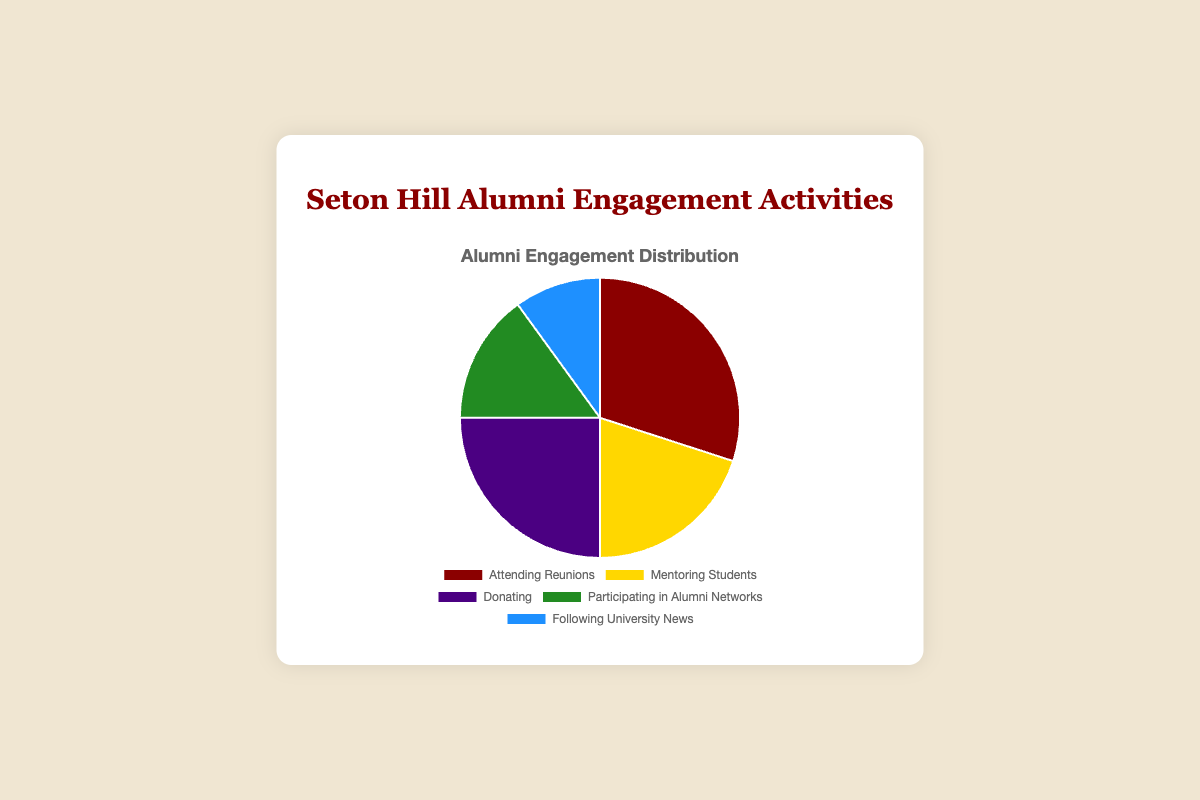Which activity has the highest percentage of alumni engagement? To determine this, look at the percentages for each activity and find the highest one. "Attending Reunions" has the highest percentage at 30%.
Answer: Attending Reunions What is the total percentage of alumni participating in "Mentoring Students" and "Donating"? Add the percentages for "Mentoring Students" (20%) and "Donating" (25%). The sum is 20% + 25% = 45%.
Answer: 45% Which engagement activity has the smallest percentage of alumni participation? Compare all the provided percentages and identify the smallest one. "Following University News" has the smallest percentage at 10%.
Answer: Following University News Is the percentage of alumni "Donating" greater than the percentage of those "Participating in Alumni Networks"? Compare the percentages for "Donating" (25%) and "Participating in Alumni Networks" (15%). 25% is greater than 15%.
Answer: Yes What is the difference in percentage between alumni "Attending Reunions" and those "Following University News"? Subtract the percentage for "Following University News" (10%) from "Attending Reunions" (30%). The difference is 30% - 10% = 20%.
Answer: 20% How many activities have a higher engagement percentage than "Participating in Alumni Networks"? Compare the percentage for "Participating in Alumni Networks" (15%) with the other activities. "Attending Reunions" (30%), "Mentoring Students" (20%), and "Donating" (25%) are higher. That's 3 activities.
Answer: 3 Which activities, taken together, make up half of the total alumni engagement? To find activities making up 50%, sum the percentages starting from the highest. "Attending Reunions" (30%) and "Donating" (25%) together are 30% + 25% = 55%, which is more than half.
Answer: Attending Reunions and Donating In terms of engagement percentage, is "Mentoring Students" closer to "Attending Reunions" or "Participating in Alumni Networks"? Calculate the difference between "Mentoring Students" (20%) and the other two activities. "Attending Reunions" (30%) difference is 10%, "Participating in Alumni Networks" (15%) difference is 5%. 5% is lesser, indicating it is closer.
Answer: Participating in Alumni Networks 